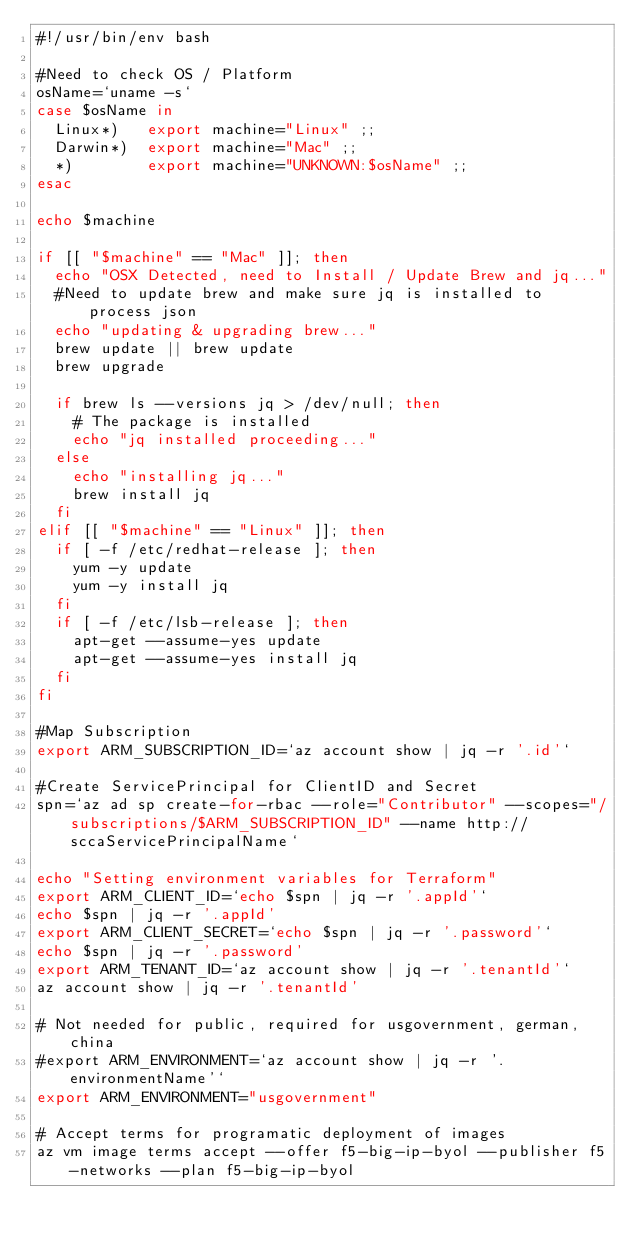Convert code to text. <code><loc_0><loc_0><loc_500><loc_500><_Bash_>#!/usr/bin/env bash

#Need to check OS / Platform
osName=`uname -s`
case $osName in
  Linux*)   export machine="Linux" ;;
  Darwin*)  export machine="Mac" ;;
  *)        export machine="UNKNOWN:$osName" ;;
esac

echo $machine

if [[ "$machine" == "Mac" ]]; then
  echo "OSX Detected, need to Install / Update Brew and jq..."
  #Need to update brew and make sure jq is installed to process json
  echo "updating & upgrading brew..."
  brew update || brew update
  brew upgrade

  if brew ls --versions jq > /dev/null; then
    # The package is installed
    echo "jq installed proceeding..."
  else
    echo "installing jq..."
    brew install jq
  fi
elif [[ "$machine" == "Linux" ]]; then
  if [ -f /etc/redhat-release ]; then
    yum -y update
    yum -y install jq
  fi
  if [ -f /etc/lsb-release ]; then
    apt-get --assume-yes update
    apt-get --assume-yes install jq
  fi
fi

#Map Subscription
export ARM_SUBSCRIPTION_ID=`az account show | jq -r '.id'`

#Create ServicePrincipal for ClientID and Secret
spn=`az ad sp create-for-rbac --role="Contributor" --scopes="/subscriptions/$ARM_SUBSCRIPTION_ID" --name http://sccaServicePrincipalName`

echo "Setting environment variables for Terraform"
export ARM_CLIENT_ID=`echo $spn | jq -r '.appId'`
echo $spn | jq -r '.appId'
export ARM_CLIENT_SECRET=`echo $spn | jq -r '.password'`
echo $spn | jq -r '.password'
export ARM_TENANT_ID=`az account show | jq -r '.tenantId'`
az account show | jq -r '.tenantId'

# Not needed for public, required for usgovernment, german, china
#export ARM_ENVIRONMENT=`az account show | jq -r '.environmentName'`
export ARM_ENVIRONMENT="usgovernment"

# Accept terms for programatic deployment of images
az vm image terms accept --offer f5-big-ip-byol --publisher f5-networks --plan f5-big-ip-byol</code> 